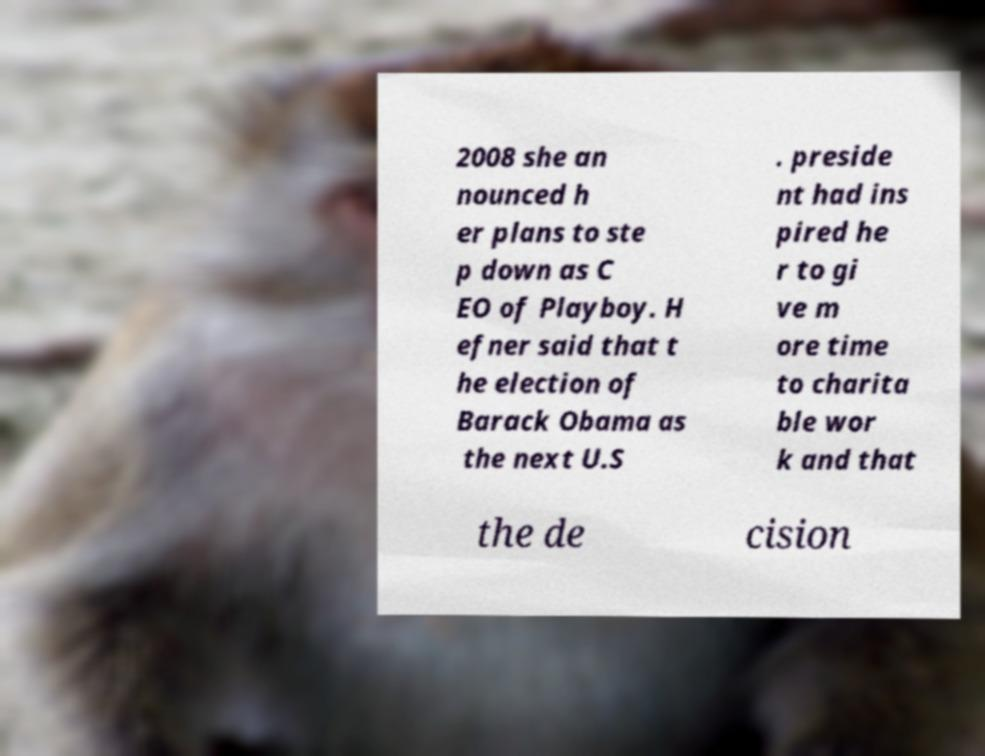I need the written content from this picture converted into text. Can you do that? 2008 she an nounced h er plans to ste p down as C EO of Playboy. H efner said that t he election of Barack Obama as the next U.S . preside nt had ins pired he r to gi ve m ore time to charita ble wor k and that the de cision 